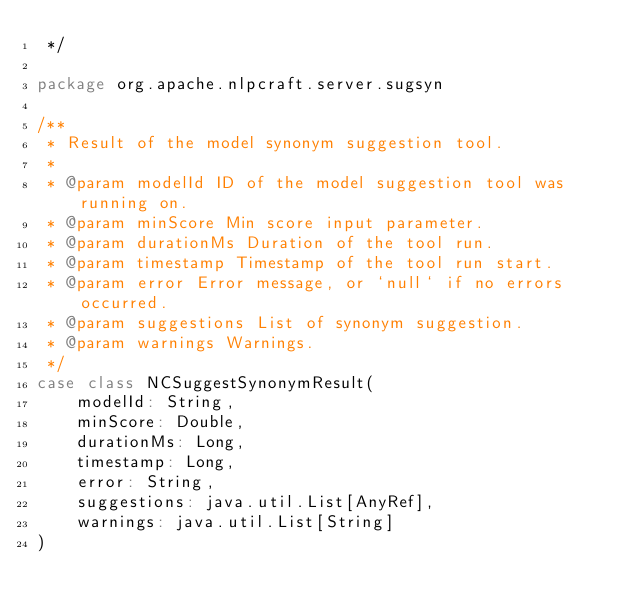Convert code to text. <code><loc_0><loc_0><loc_500><loc_500><_Scala_> */

package org.apache.nlpcraft.server.sugsyn

/**
 * Result of the model synonym suggestion tool.
 *
 * @param modelId ID of the model suggestion tool was running on.
 * @param minScore Min score input parameter.
 * @param durationMs Duration of the tool run.
 * @param timestamp Timestamp of the tool run start.
 * @param error Error message, or `null` if no errors occurred.
 * @param suggestions List of synonym suggestion.
 * @param warnings Warnings.
 */
case class NCSuggestSynonymResult(
    modelId: String,
    minScore: Double,
    durationMs: Long,
    timestamp: Long,
    error: String,
    suggestions: java.util.List[AnyRef],
    warnings: java.util.List[String]
)
</code> 